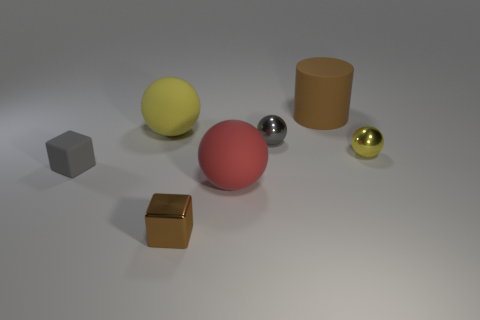Subtract all large red balls. How many balls are left? 3 Subtract all green cylinders. How many yellow balls are left? 2 Subtract all gray spheres. How many spheres are left? 3 Add 3 cyan shiny balls. How many objects exist? 10 Subtract 1 spheres. How many spheres are left? 3 Subtract all blue cubes. Subtract all brown cylinders. How many cubes are left? 2 Subtract all red cylinders. Subtract all small brown metallic blocks. How many objects are left? 6 Add 5 small brown blocks. How many small brown blocks are left? 6 Add 7 large red shiny cylinders. How many large red shiny cylinders exist? 7 Subtract 0 purple balls. How many objects are left? 7 